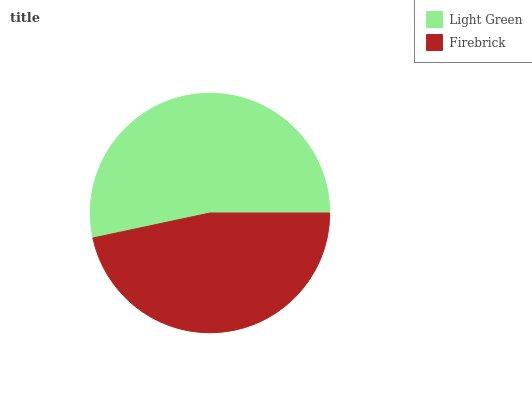Is Firebrick the minimum?
Answer yes or no. Yes. Is Light Green the maximum?
Answer yes or no. Yes. Is Firebrick the maximum?
Answer yes or no. No. Is Light Green greater than Firebrick?
Answer yes or no. Yes. Is Firebrick less than Light Green?
Answer yes or no. Yes. Is Firebrick greater than Light Green?
Answer yes or no. No. Is Light Green less than Firebrick?
Answer yes or no. No. Is Light Green the high median?
Answer yes or no. Yes. Is Firebrick the low median?
Answer yes or no. Yes. Is Firebrick the high median?
Answer yes or no. No. Is Light Green the low median?
Answer yes or no. No. 